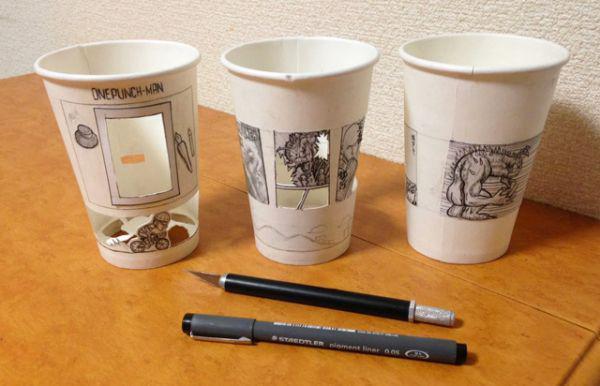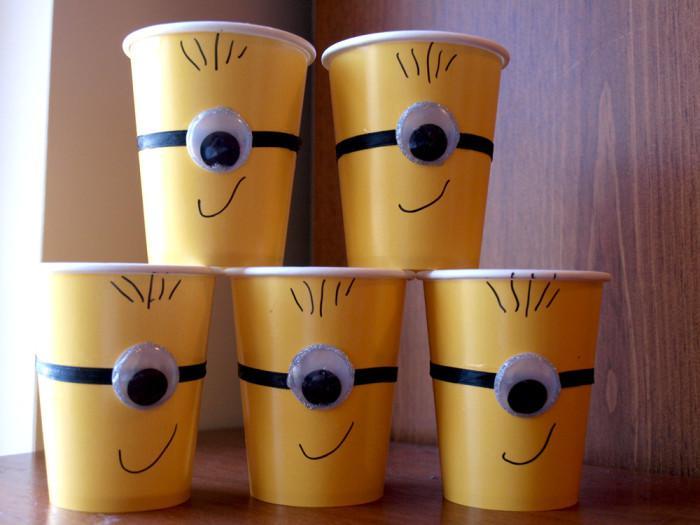The first image is the image on the left, the second image is the image on the right. Evaluate the accuracy of this statement regarding the images: "The left image shows a thumb on the left side of a cup, and the right image includes a cup with a cartoon face on it and contains no more than two cups.". Is it true? Answer yes or no. No. The first image is the image on the left, the second image is the image on the right. Evaluate the accuracy of this statement regarding the images: "In at least one image there are three paper cups.". Is it true? Answer yes or no. Yes. 